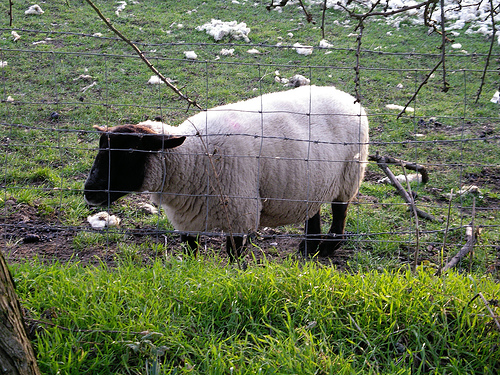<image>
Is there a sheep on the grass? Yes. Looking at the image, I can see the sheep is positioned on top of the grass, with the grass providing support. Is the sheep in front of the fence? No. The sheep is not in front of the fence. The spatial positioning shows a different relationship between these objects. 